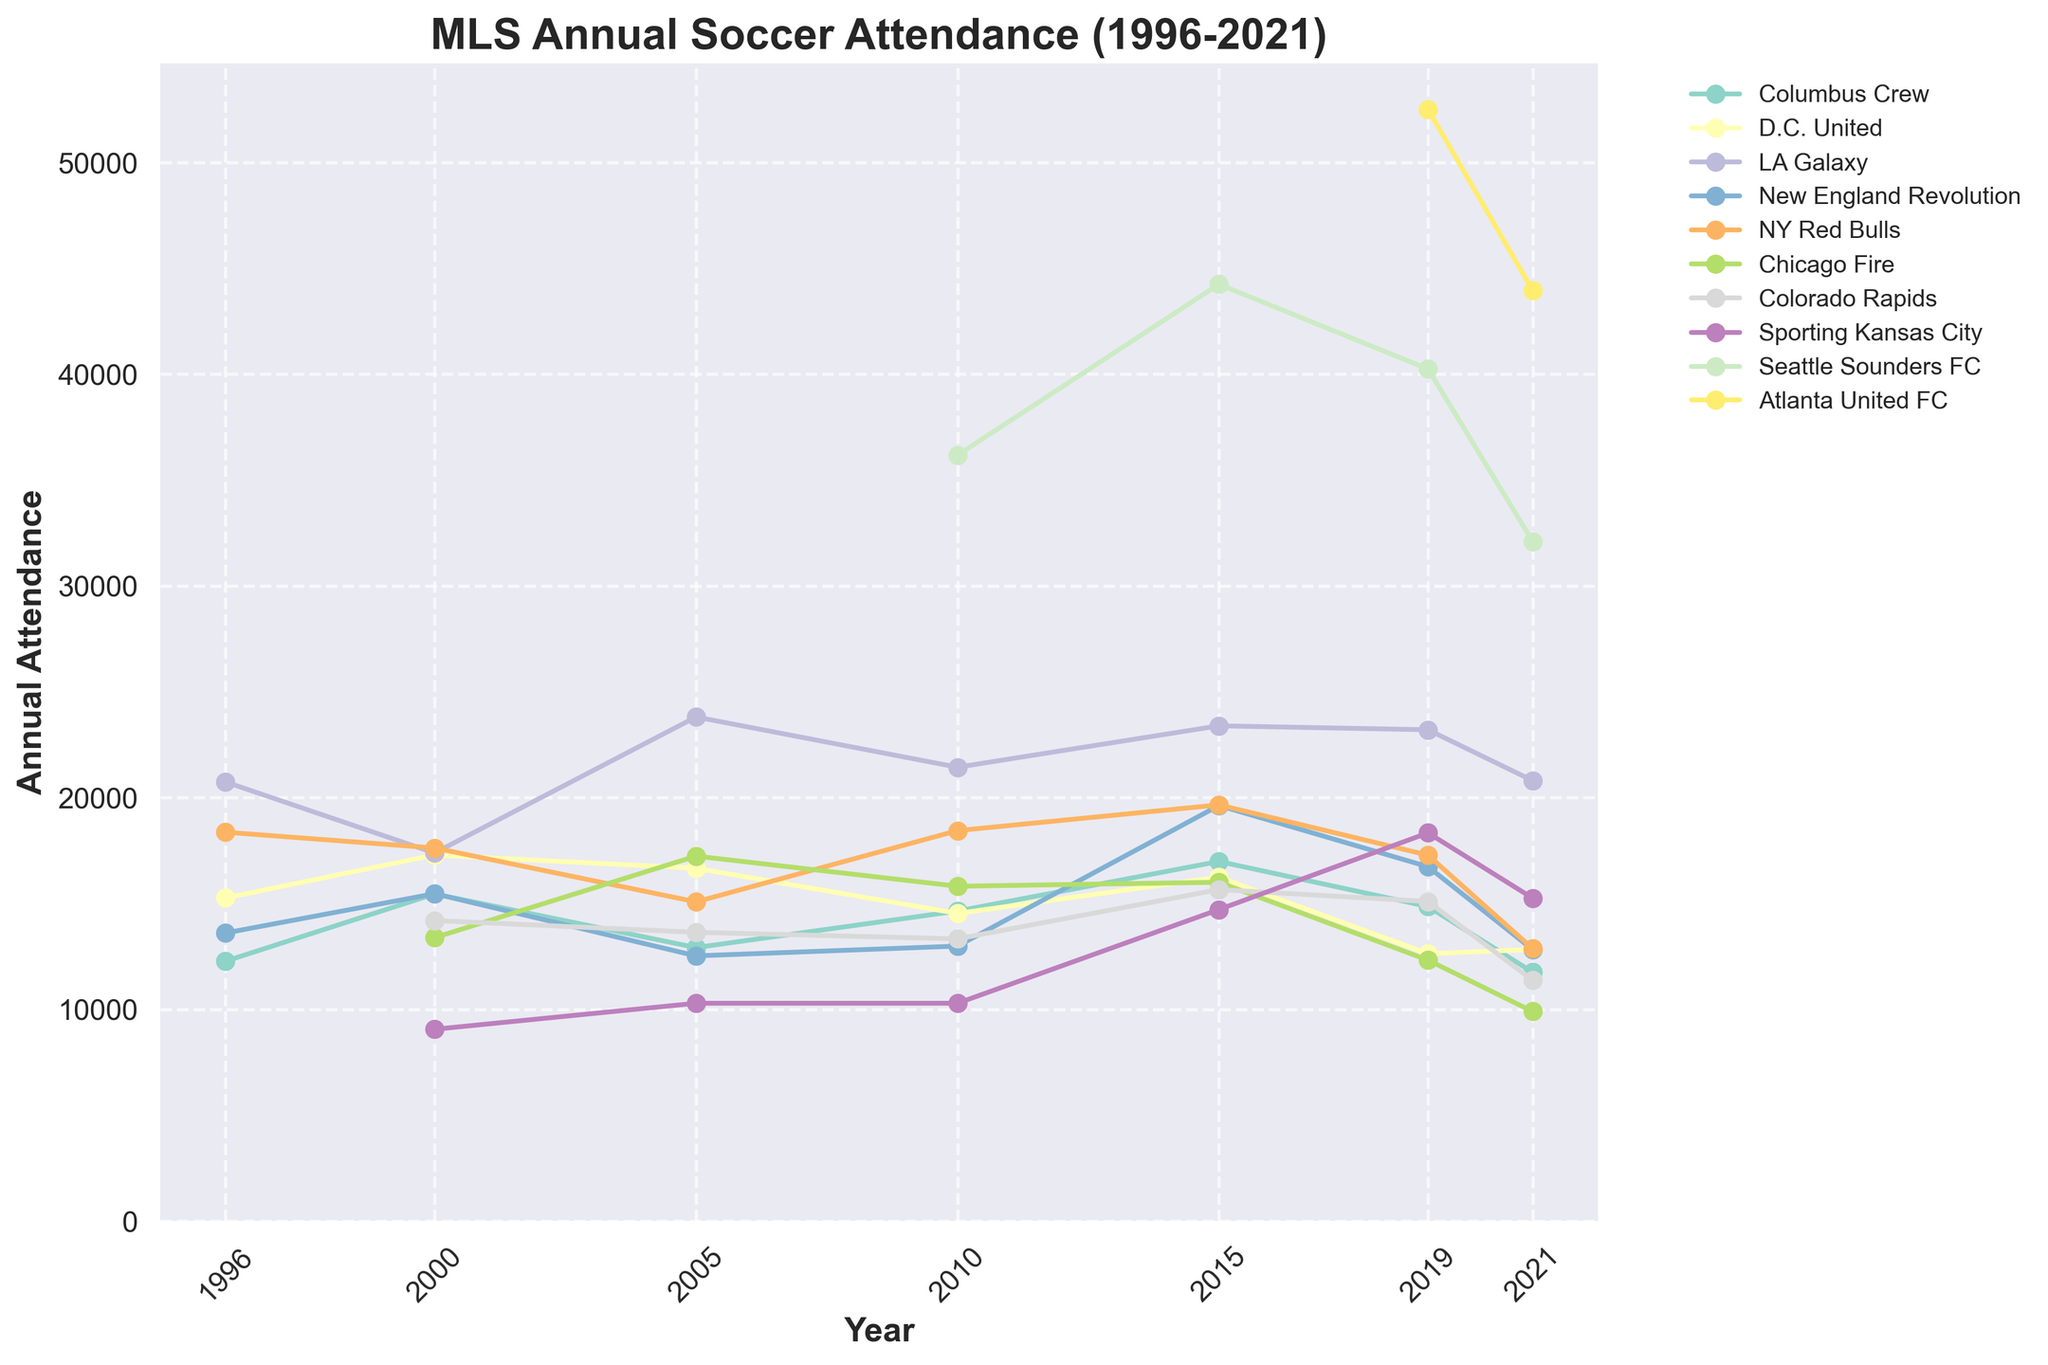Which team had the highest annual attendance in 2019? By examining the highest point in 2019, we can see that Atlanta United FC has the highest attendance.
Answer: Atlanta United FC Which team showed the greatest decline in attendance from 2019 to 2021? Looking at the lines between 2019 and 2021, the LA Galaxy's attendance declined from 23205 to 20804, which is the largest decline.
Answer: LA Galaxy What's the average annual attendance for the Columbus Crew from 1996 to 2021? Summing up the annual attendance for Columbus Crew from 1996, 2000, 2005, 2010, 2015, 2019, and 2021, we get 12274 + 15451 + 12916 + 14642 + 16985 + 14856 + 11754 = 98978. The average is 98978 / 7 = 14139.714
Answer: 14140 Which teams had a higher attendance in 2010 compared to 2005? Comparing the attendance figures, D.C. United (14532 > 16664), LA Galaxy (21436 > 23809), and Seattle Sounders FC (36173 in 2010) all had higher attendance in 2010 compared to 2005.
Answer: D.C. United, LA Galaxy, Seattle Sounders FC Which team had a steady increase in attendance from 2010 to 2015? By looking at the gradual rise in lines between 2010 and 2015, Seattle Sounders FC shows a steady increase from 36173 to 44247.
Answer: Seattle Sounders FC How many teams had an attendance greater than 20000 in 2015? In 2015, we check the y-axis values, and three teams—LA Galaxy (23392), Seattle Sounders FC (44247), and Atlanta United FC (52510)—had attendances over 20000.
Answer: 3 Which team has the most fluctuation in annual attendance from 1996 to 2021? By examining the variance in the heights of the lines across all years, the Chicago Fire shows significant fluctuations, especially with a notable increase and then a drop.
Answer: Chicago Fire What's the total attendance for NY Red Bulls and Chicago Fire in 2000? Summing the attendance values for NY Red Bulls (17621) and Chicago Fire (13387) in 2000, we get 17621 + 13387 = 31008.
Answer: 31008 